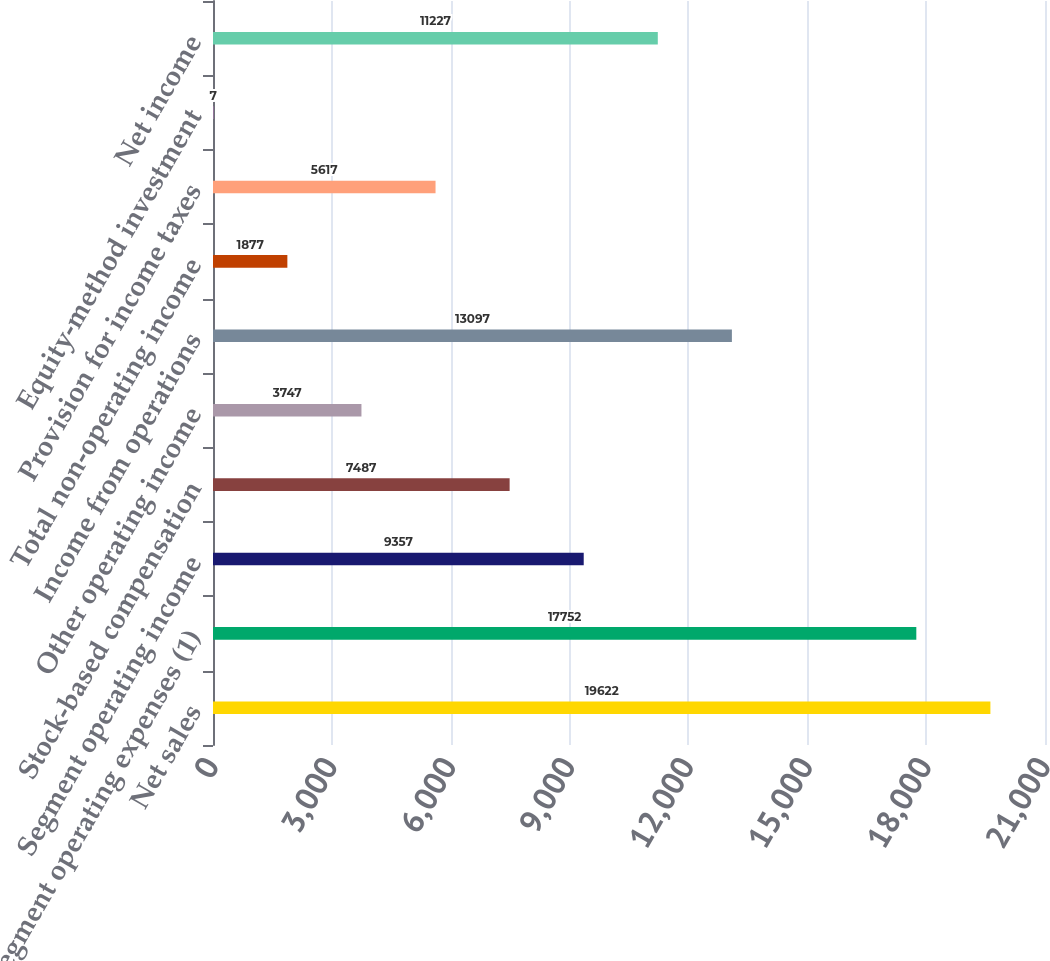Convert chart to OTSL. <chart><loc_0><loc_0><loc_500><loc_500><bar_chart><fcel>Net sales<fcel>Segment operating expenses (1)<fcel>Segment operating income<fcel>Stock-based compensation<fcel>Other operating income<fcel>Income from operations<fcel>Total non-operating income<fcel>Provision for income taxes<fcel>Equity-method investment<fcel>Net income<nl><fcel>19622<fcel>17752<fcel>9357<fcel>7487<fcel>3747<fcel>13097<fcel>1877<fcel>5617<fcel>7<fcel>11227<nl></chart> 